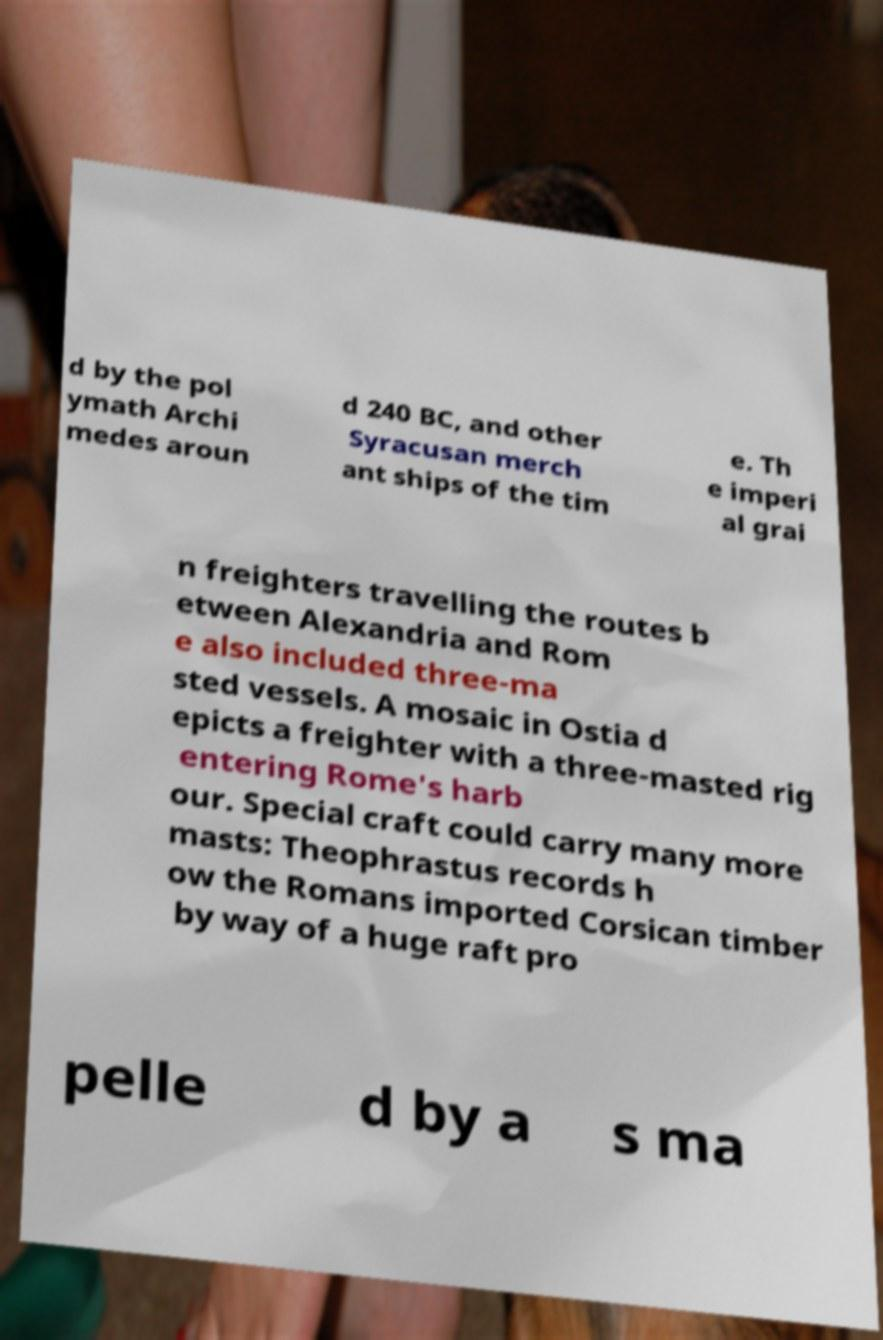There's text embedded in this image that I need extracted. Can you transcribe it verbatim? d by the pol ymath Archi medes aroun d 240 BC, and other Syracusan merch ant ships of the tim e. Th e imperi al grai n freighters travelling the routes b etween Alexandria and Rom e also included three-ma sted vessels. A mosaic in Ostia d epicts a freighter with a three-masted rig entering Rome's harb our. Special craft could carry many more masts: Theophrastus records h ow the Romans imported Corsican timber by way of a huge raft pro pelle d by a s ma 